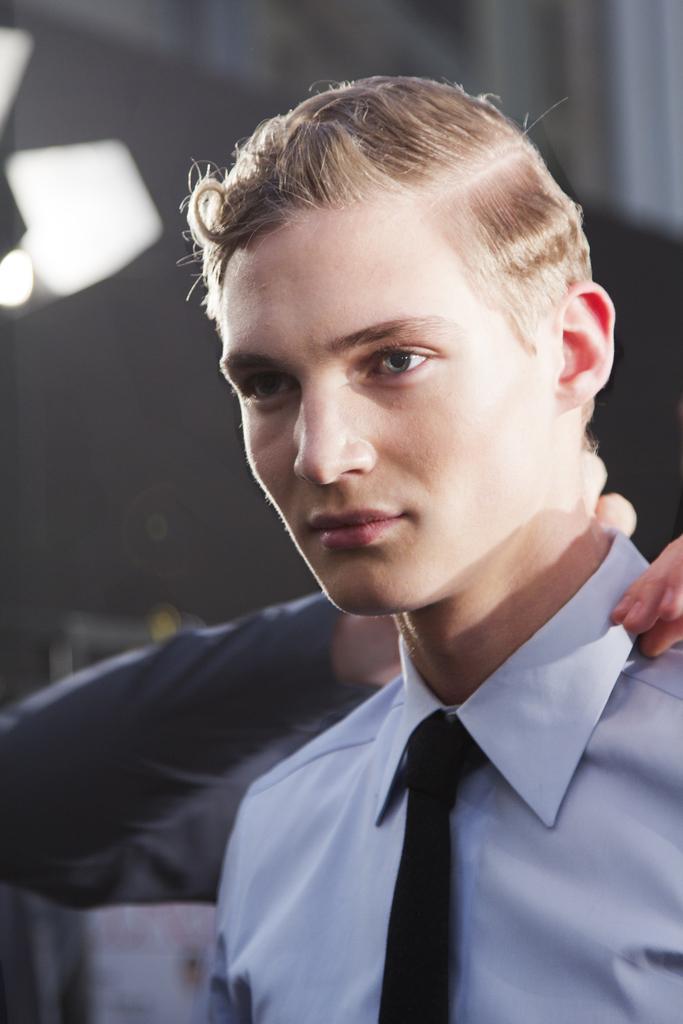Could you give a brief overview of what you see in this image? In this image I can see a person is seeing at this side. This person wore shirt, tie. Behind him there is another person adjusting this person's collar. 